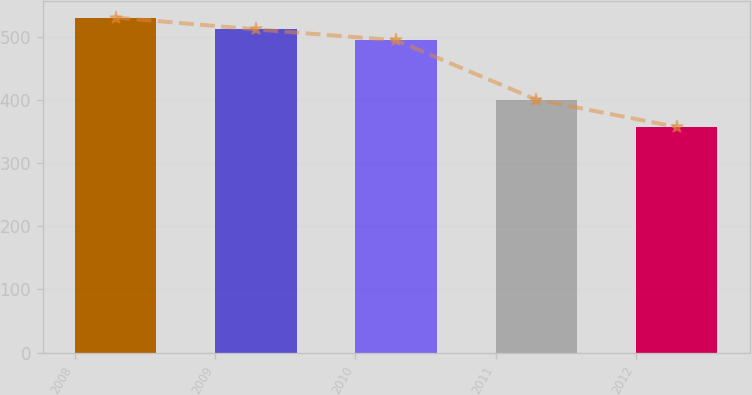Convert chart to OTSL. <chart><loc_0><loc_0><loc_500><loc_500><bar_chart><fcel>2008<fcel>2009<fcel>2010<fcel>2011<fcel>2012<nl><fcel>530<fcel>511.3<fcel>494<fcel>400<fcel>357<nl></chart> 